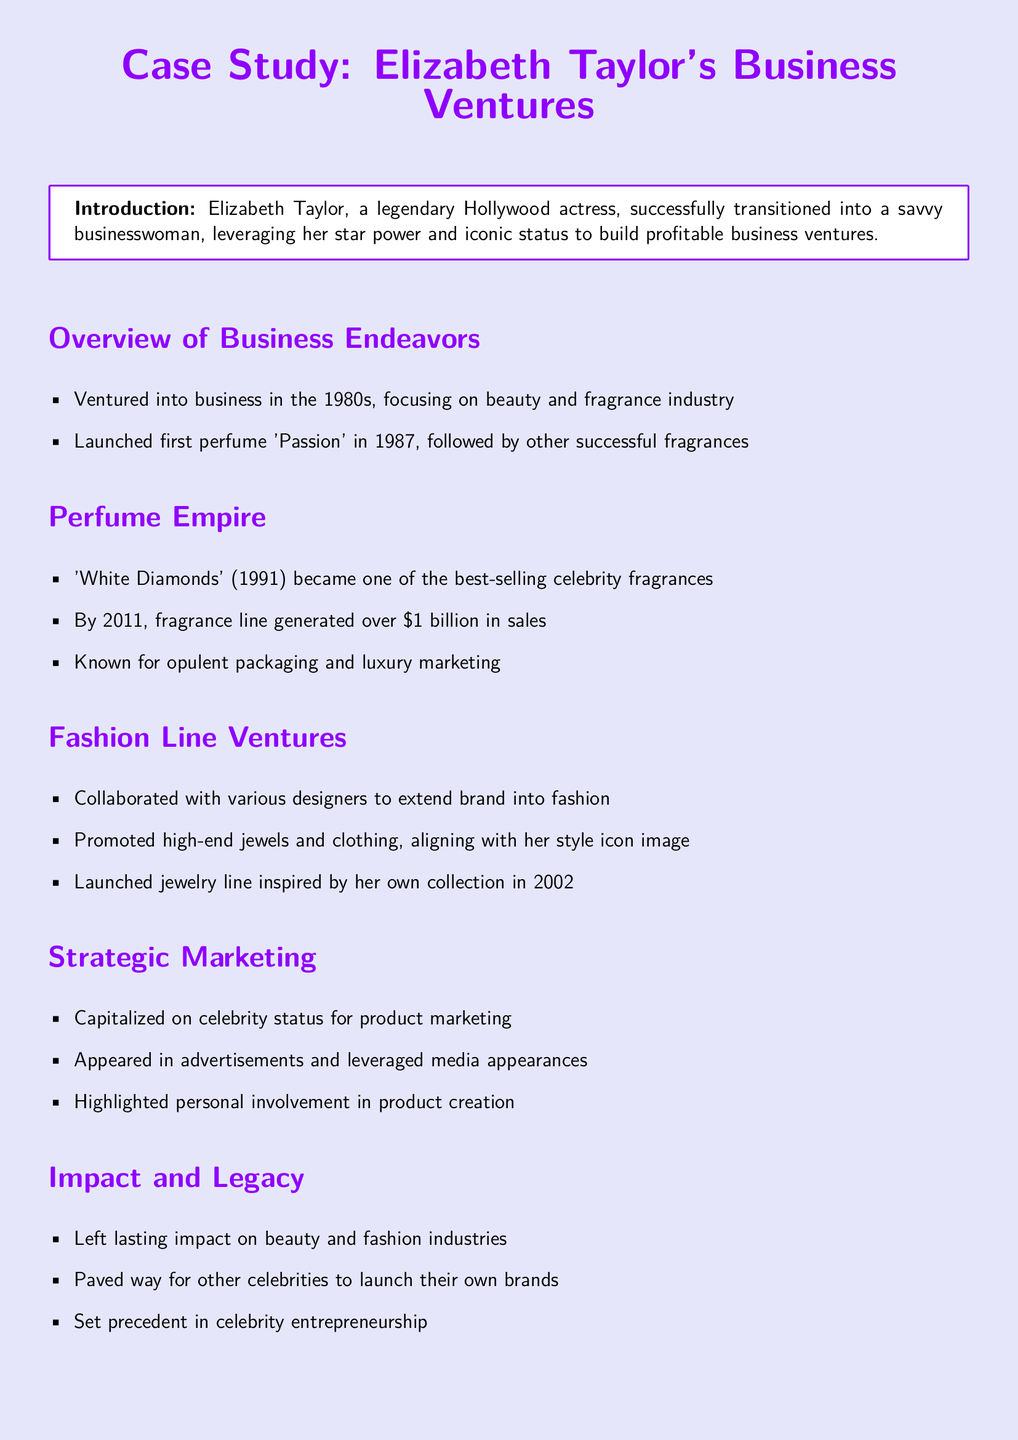What year did Elizabeth Taylor launch her first perfume? The document states that Elizabeth Taylor launched her first perfume 'Passion' in 1987.
Answer: 1987 What was one of the best-selling celebrity fragrances? The document mentions 'White Diamonds' (1991) as one of the best-selling celebrity fragrances.
Answer: White Diamonds How much in sales did the fragrance line generate by 2011? According to the document, by 2011 the fragrance line generated over $1 billion in sales.
Answer: Over $1 billion In what year did Elizabeth Taylor launch her jewelry line? The document indicates that the jewelry line was launched in 2002.
Answer: 2002 What was a key component of Elizabeth Taylor's marketing strategy? The document highlights that she capitalized on her celebrity status for product marketing.
Answer: Celebrity status What impact did Elizabeth Taylor have on other celebrities? The document states that she paved the way for other celebrities to launch their own brands.
Answer: Paved the way What type of products did Elizabeth Taylor promote alongside her fragrances? The document mentions that she promoted high-end jewels and clothing.
Answer: High-end jewels and clothing What was the strategic focus of Elizabeth Taylor's business ventures? The document emphasizes her focus on beauty and fragrance industry as part of her business ventures.
Answer: Beauty and fragrance industry What does the conclusion suggest about Elizabeth Taylor's brand? The conclusion states that her ventures cemented her legacy as a business icon.
Answer: Business icon 